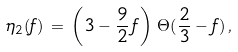<formula> <loc_0><loc_0><loc_500><loc_500>\eta _ { 2 } ( f ) \, = \, \left ( 3 - \frac { 9 } { 2 } \, f \right ) \, \Theta ( \frac { 2 } { 3 } - f ) \, ,</formula> 